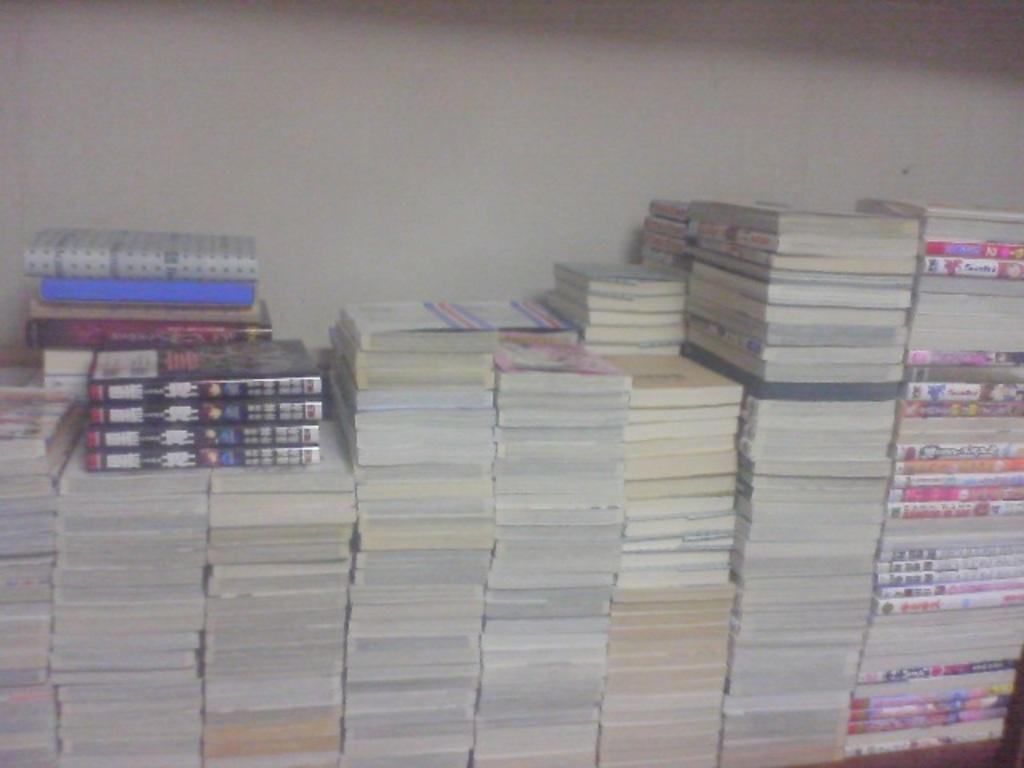Please provide a concise description of this image. In this image I can see a number of books. 